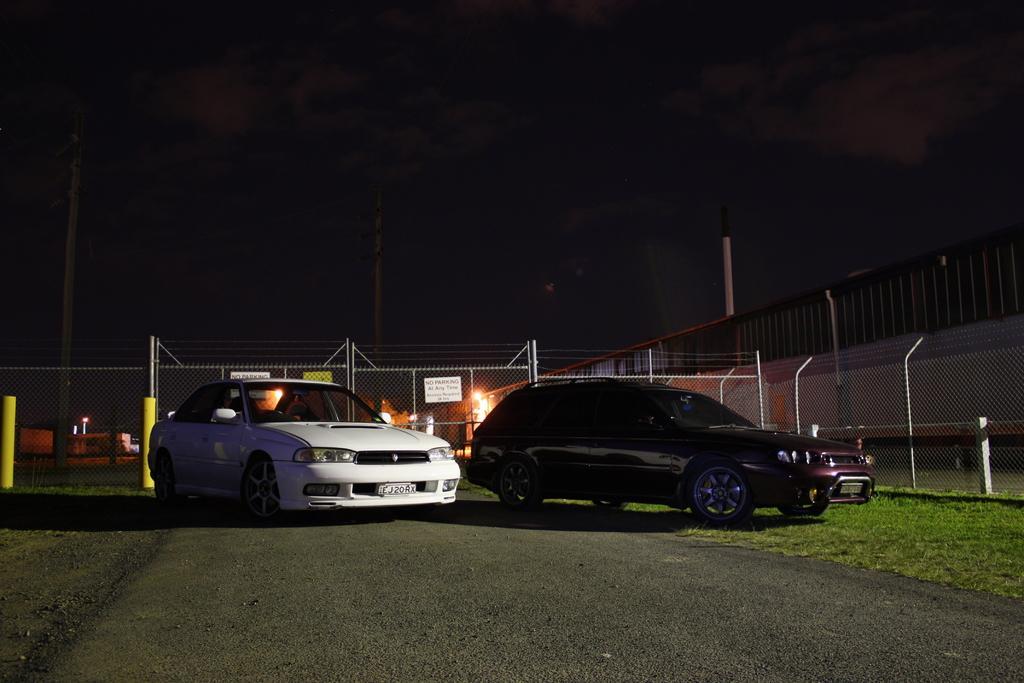How would you summarize this image in a sentence or two? This picture is clicked outside. In the foreground we can see the green grass and we can see the cars parked on the ground. In the background we can see the sky, poles, metal rods, mesh, lights and the text on the boards and we can see some other objects. 